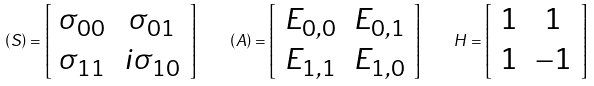<formula> <loc_0><loc_0><loc_500><loc_500>\left ( S \right ) = \left [ \begin{array} { c c } \sigma _ { 0 0 } & \sigma _ { 0 1 } \\ \sigma _ { 1 1 } & i \sigma _ { 1 0 } \end{array} \right ] \quad \left ( A \right ) = \left [ \begin{array} { c c } E _ { 0 , 0 } & E _ { 0 , 1 } \\ E _ { 1 , 1 } & E _ { 1 , 0 } \end{array} \right ] \quad H = \left [ \begin{array} { c c } 1 & 1 \\ 1 & - 1 \end{array} \right ]</formula> 